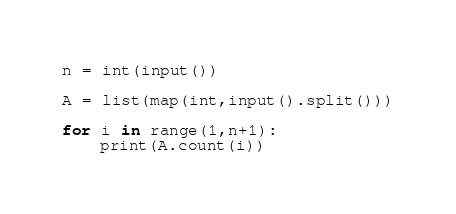<code> <loc_0><loc_0><loc_500><loc_500><_Python_>n = int(input())

A = list(map(int,input().split()))

for i in range(1,n+1):
    print(A.count(i))</code> 